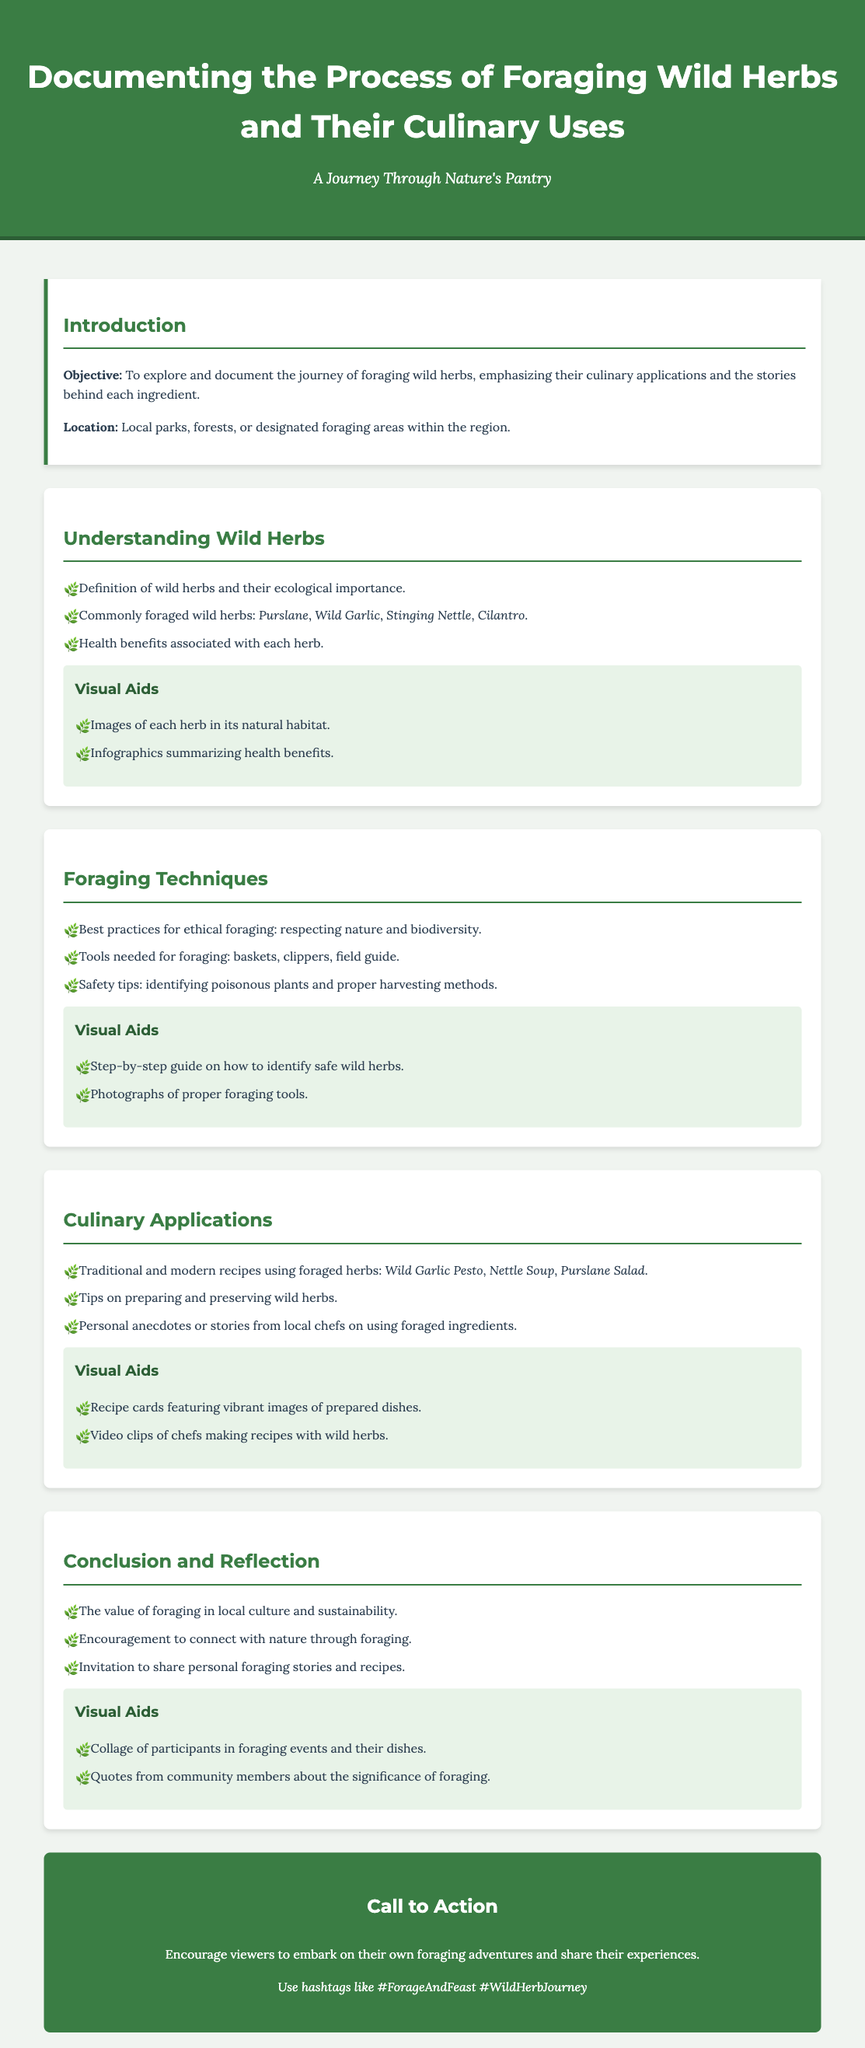What is the title of the document? The title of the document is found in the header section.
Answer: Documenting the Process of Foraging Wild Herbs and Their Culinary Uses Where is the focus of the foraging activities? The focus is mentioned in the introduction section as the specific areas where foraging takes place.
Answer: Local parks, forests, or designated foraging areas within the region Name two examples of commonly foraged wild herbs. This information is provided in the "Understanding Wild Herbs" section of the document.
Answer: Purslane, Wild Garlic What is one safety tip mentioned for foraging? The document outlines best practices in the "Foraging Techniques" section.
Answer: Identifying poisonous plants What is the main theme discussed in the conclusion? The conclusion summarizes the overall value of the practices discussed in the document.
Answer: The value of foraging in local culture and sustainability Which dish is suggested in the culinary applications section? This information can be found under "Culinary Applications" where recipes are listed.
Answer: Wild Garlic Pesto What type of visual aids accompany the "Culinary Applications" section? The document specifies the types of visual aids included with the recipes.
Answer: Recipe cards featuring vibrant images of prepared dishes How are participants encouraged to engage with foraging? The call to action section provides a clear invitation to the audience related to foraging.
Answer: Embark on their own foraging adventures 